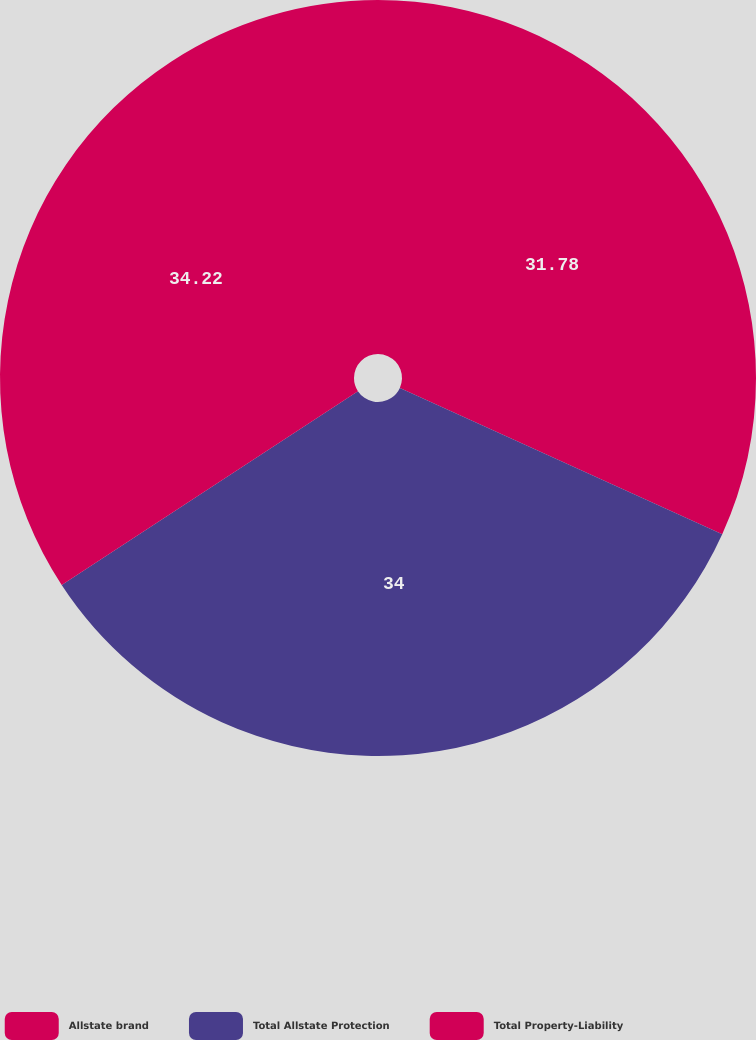Convert chart. <chart><loc_0><loc_0><loc_500><loc_500><pie_chart><fcel>Allstate brand<fcel>Total Allstate Protection<fcel>Total Property-Liability<nl><fcel>31.78%<fcel>34.0%<fcel>34.22%<nl></chart> 